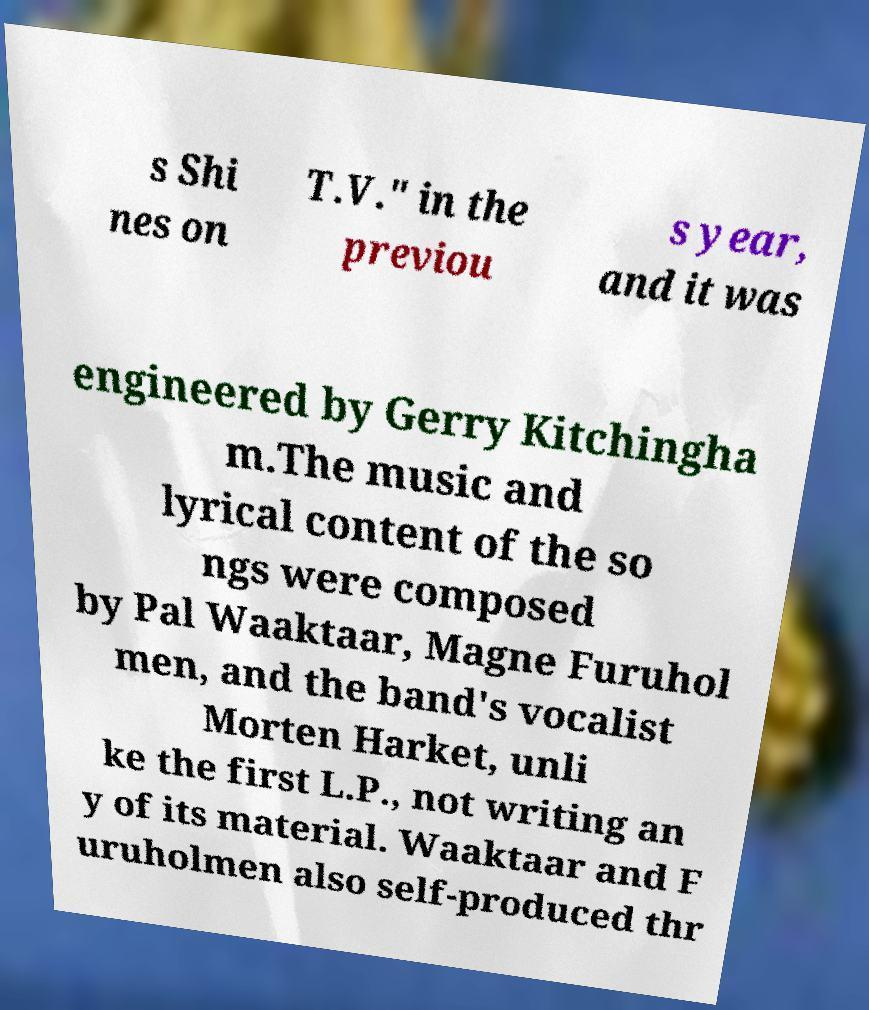Please identify and transcribe the text found in this image. s Shi nes on T.V." in the previou s year, and it was engineered by Gerry Kitchingha m.The music and lyrical content of the so ngs were composed by Pal Waaktaar, Magne Furuhol men, and the band's vocalist Morten Harket, unli ke the first L.P., not writing an y of its material. Waaktaar and F uruholmen also self-produced thr 